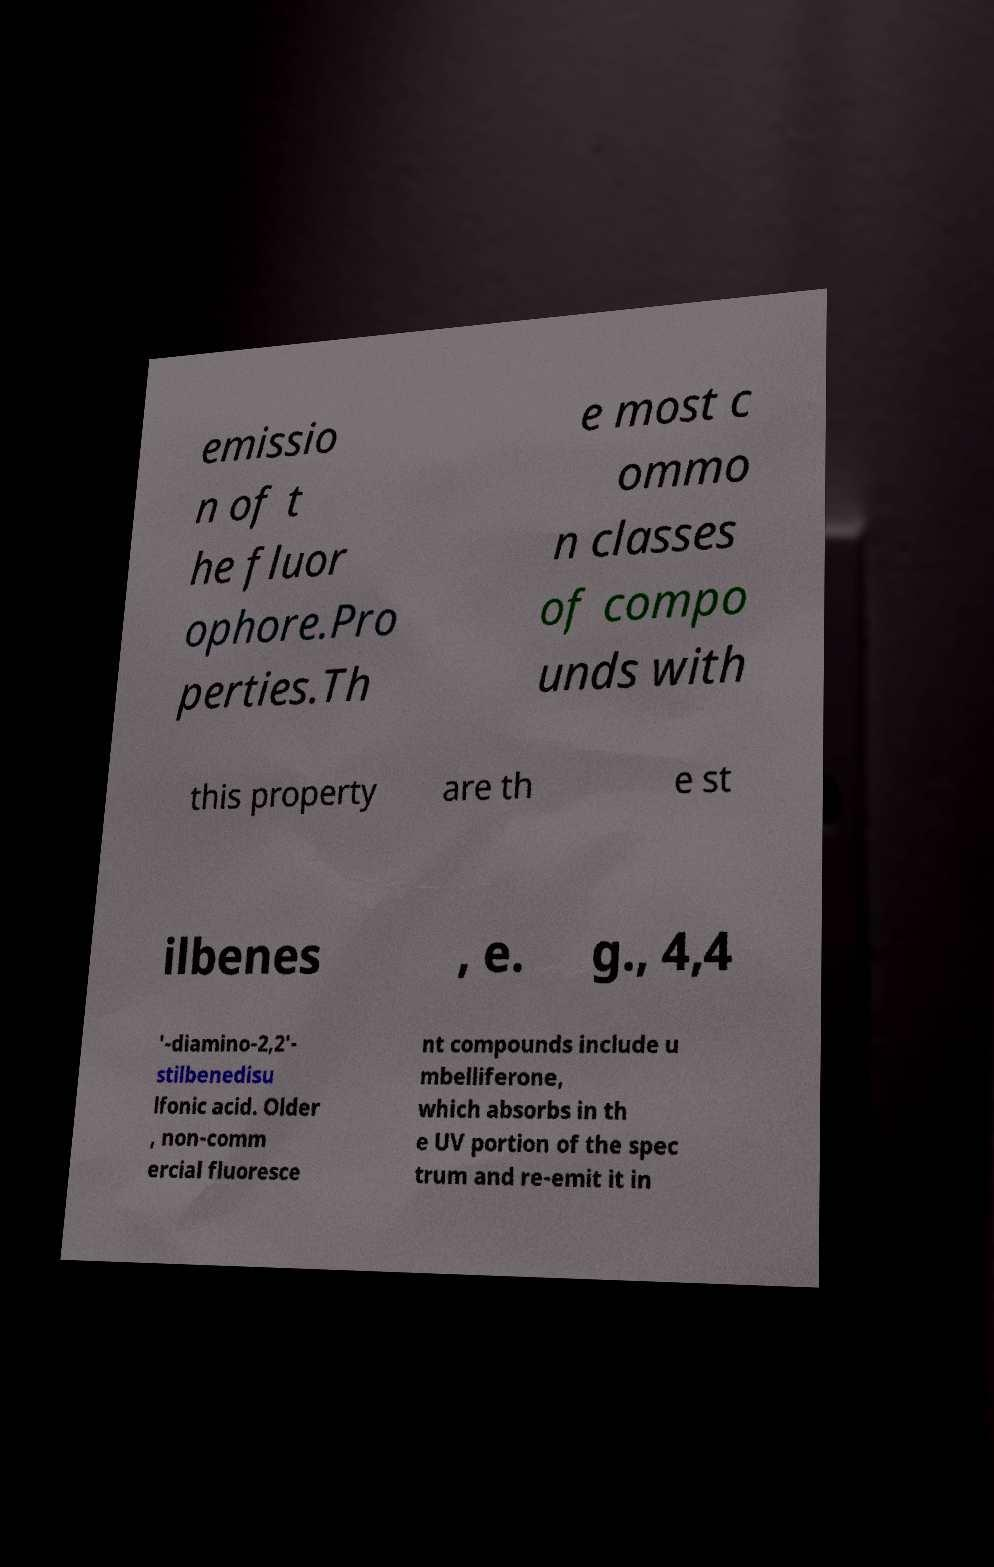Please read and relay the text visible in this image. What does it say? emissio n of t he fluor ophore.Pro perties.Th e most c ommo n classes of compo unds with this property are th e st ilbenes , e. g., 4,4 ′-diamino-2,2′- stilbenedisu lfonic acid. Older , non-comm ercial fluoresce nt compounds include u mbelliferone, which absorbs in th e UV portion of the spec trum and re-emit it in 